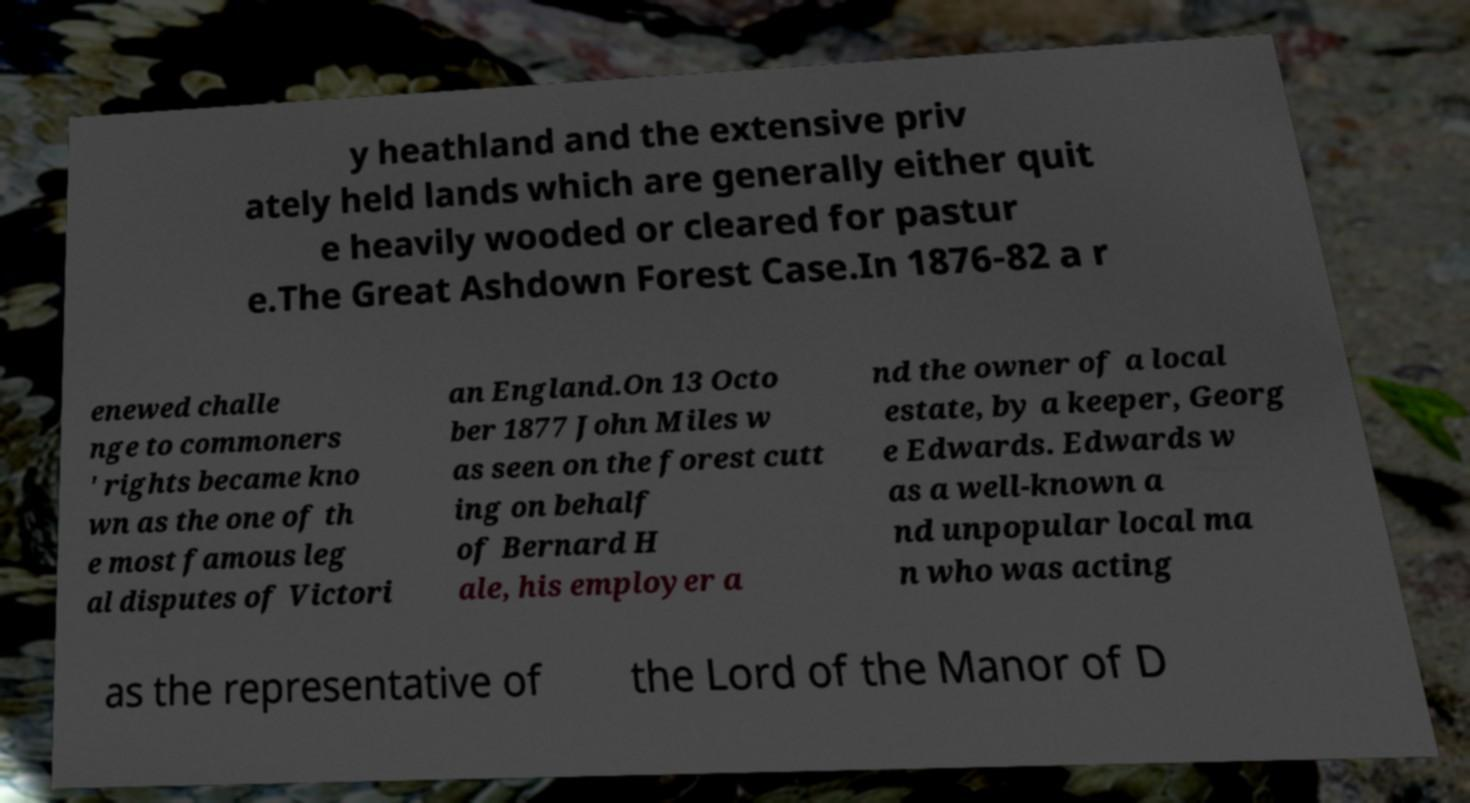What messages or text are displayed in this image? I need them in a readable, typed format. y heathland and the extensive priv ately held lands which are generally either quit e heavily wooded or cleared for pastur e.The Great Ashdown Forest Case.In 1876-82 a r enewed challe nge to commoners ' rights became kno wn as the one of th e most famous leg al disputes of Victori an England.On 13 Octo ber 1877 John Miles w as seen on the forest cutt ing on behalf of Bernard H ale, his employer a nd the owner of a local estate, by a keeper, Georg e Edwards. Edwards w as a well-known a nd unpopular local ma n who was acting as the representative of the Lord of the Manor of D 